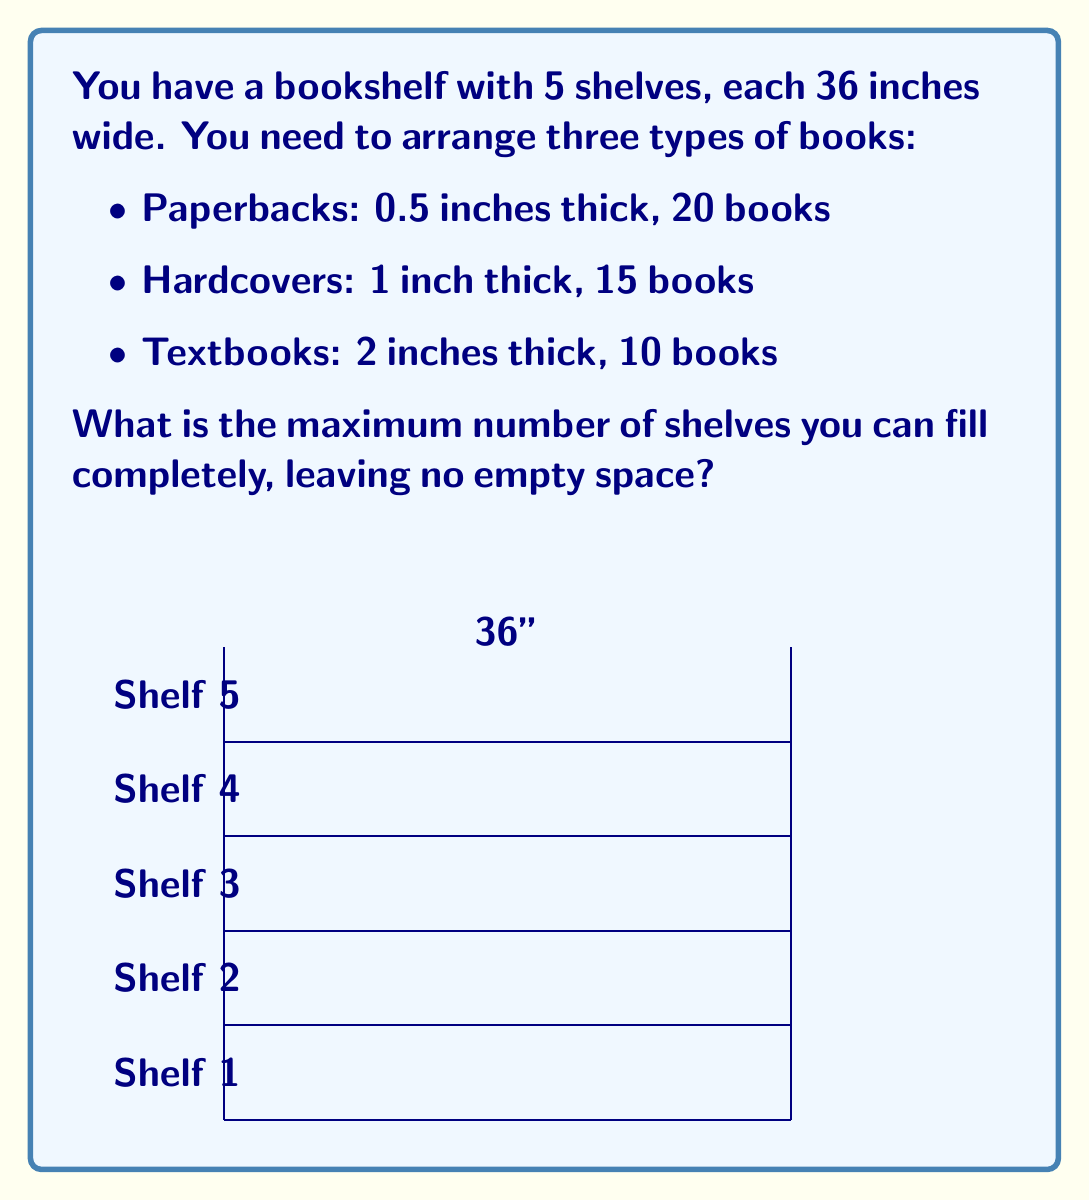Solve this math problem. Let's approach this step-by-step:

1) First, calculate the total width of each book type:
   - Paperbacks: $20 \times 0.5 = 10$ inches
   - Hardcovers: $15 \times 1 = 15$ inches
   - Textbooks: $10 \times 2 = 20$ inches

2) Total width of all books:
   $$ 10 + 15 + 20 = 45 \text{ inches} $$

3) Each shelf is 36 inches wide, so we need to find how many complete shelves we can fill:
   $$ \text{Number of full shelves} = \left\lfloor\frac{45}{36}\right\rfloor = 1 $$
   Where $\lfloor \cdot \rfloor$ denotes the floor function.

4) After filling one shelf completely, we have:
   $$ 45 - 36 = 9 \text{ inches of books left} $$

5) These 9 inches will partially fill a second shelf, but not completely.

Therefore, the maximum number of shelves that can be filled completely is 1.
Answer: 1 shelf 